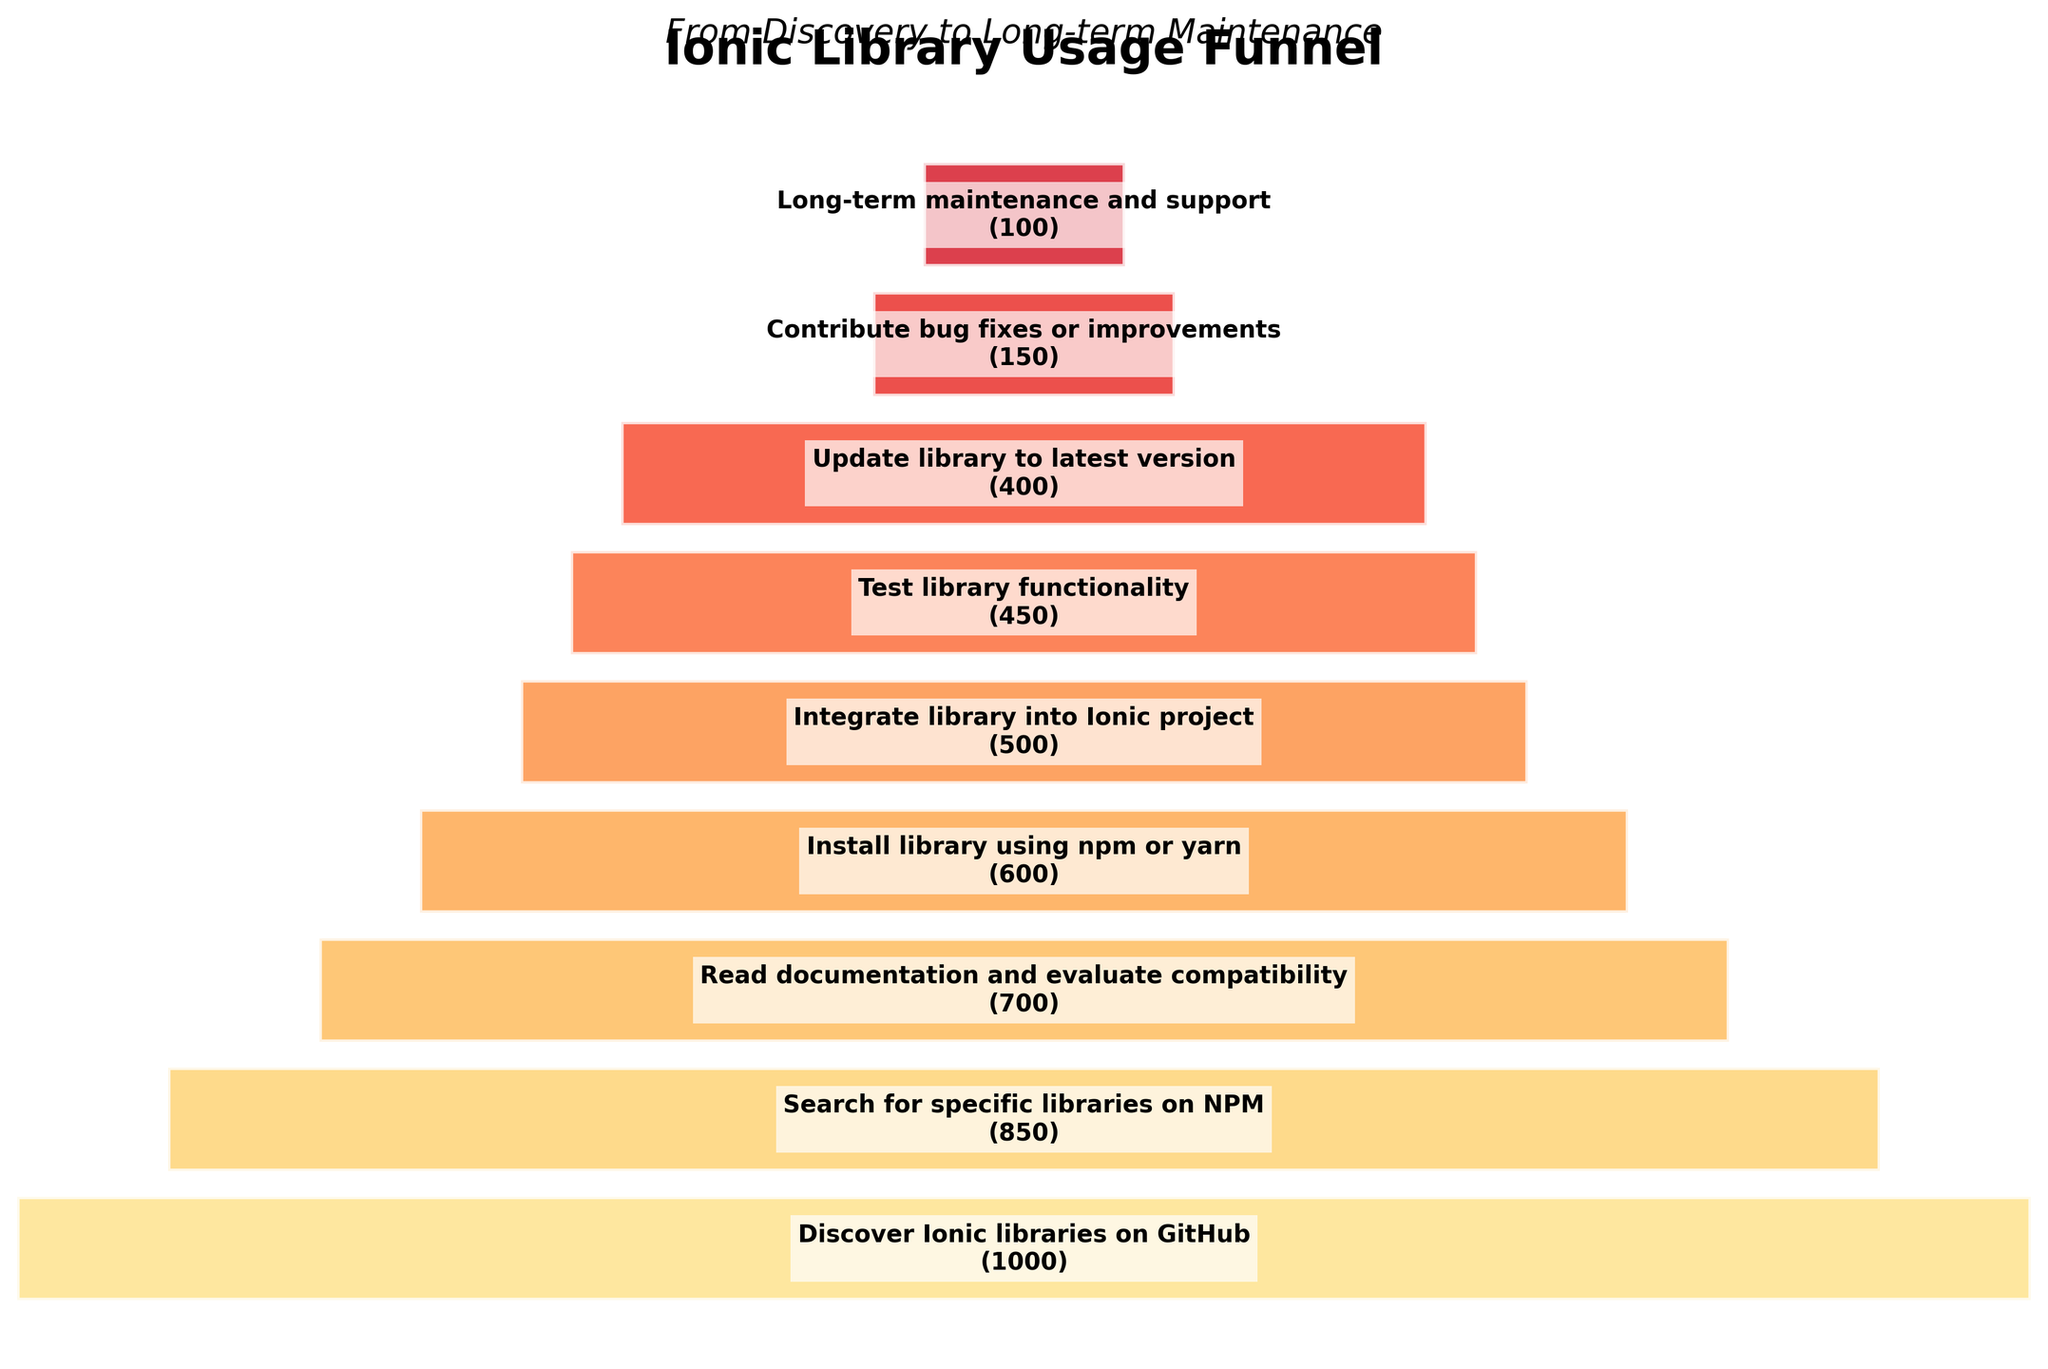What's the title of the plot? The title is located at the top of the plot and is clearly labeled.
Answer: Ionic Library Usage Funnel How many developers contribute bug fixes or improvements compared to those who integrate the library into their Ionic project? From the data, 150 developers contribute bug fixes or improvements, while 500 developers integrate the library into their project. The difference is 500 - 150 = 350.
Answer: 350 What's the most significant drop between any two stages in the funnel? The largest drop in developer numbers occurs between "Read documentation and evaluate compatibility" (700) and "Install library using npm or yarn" (600). The difference is 700 - 600 = 100.
Answer: 100 Which stage has the lowest number of developers, and how many developers are at this stage? The stage with the lowest number of developers is "Long-term maintenance and support", with 100 developers.
Answer: Long-term maintenance and support, 100 Which two stages in the funnel have the closest number of developers? The stages "Update library to latest version" (400) and "Contribute bug fixes or improvements" (150) differ by only 50 developers, the closest difference.
Answer: Update library to latest version, Contribute bug fixes or improvements How many developers drop off between discovering Ionic libraries and testing their functionality? There are 1000 developers at the discovery stage and 450 developers at the testing stage. The drop off is 1000 - 450 = 550 developers.
Answer: 550 Compare the number of developers who read documentation and those who test library functionality. Which group is larger and by how much? 700 developers read documentation, while 450 test library functionality. 700 - 450 = 250, so the group that reads documentation is larger by 250 developers.
Answer: Read documentation, 250 What's the average number of developers across all stages? Sum the number of developers at each stage (1000 + 850 + 700 + 600 + 500 + 450 + 400 + 150 + 100 = 4750) and divide by the number of stages (9). The average is 4750 / 9 ≈ 527.78.
Answer: 527.78 What is the dominant color scheme used in the funnel chart? The funnel chart predominantly uses shades of yellow to red.
Answer: Yellow to red Which stages show a drop of more than 100 developers to the next stage? The drops between "Discover Ionic libraries on GitHub" (1000) to "Search for specific libraries on NPM" (850) and "Read documentation and evaluate compatibility" (700) to "Install library using npm or yarn" (600) are both more than 100 developers, with drops of 150 and 100 respectively.
Answer: Discover Ionic to Search, Read documentation to Install 